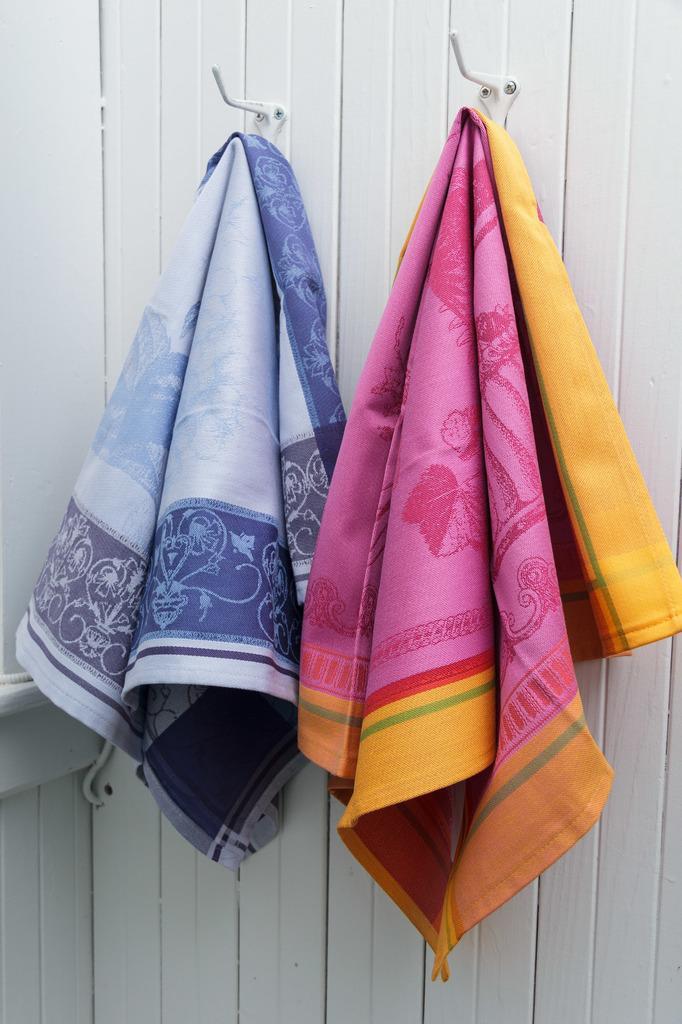Could you give a brief overview of what you see in this image? In this image we can see clothes hanged to the hooks. In the background we can see wall. 